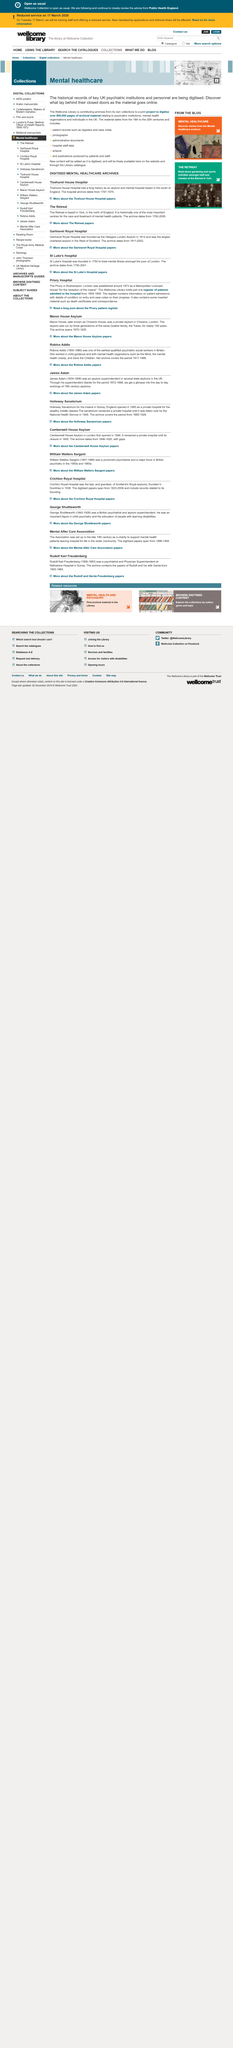Draw attention to some important aspects in this diagram. The patient register contains information on patient admissions, including details of their condition upon entry, as well as case notes on their progress. The Priory Hospital was established around 1873. The Manor House is a private asylum located in Chiswick. 